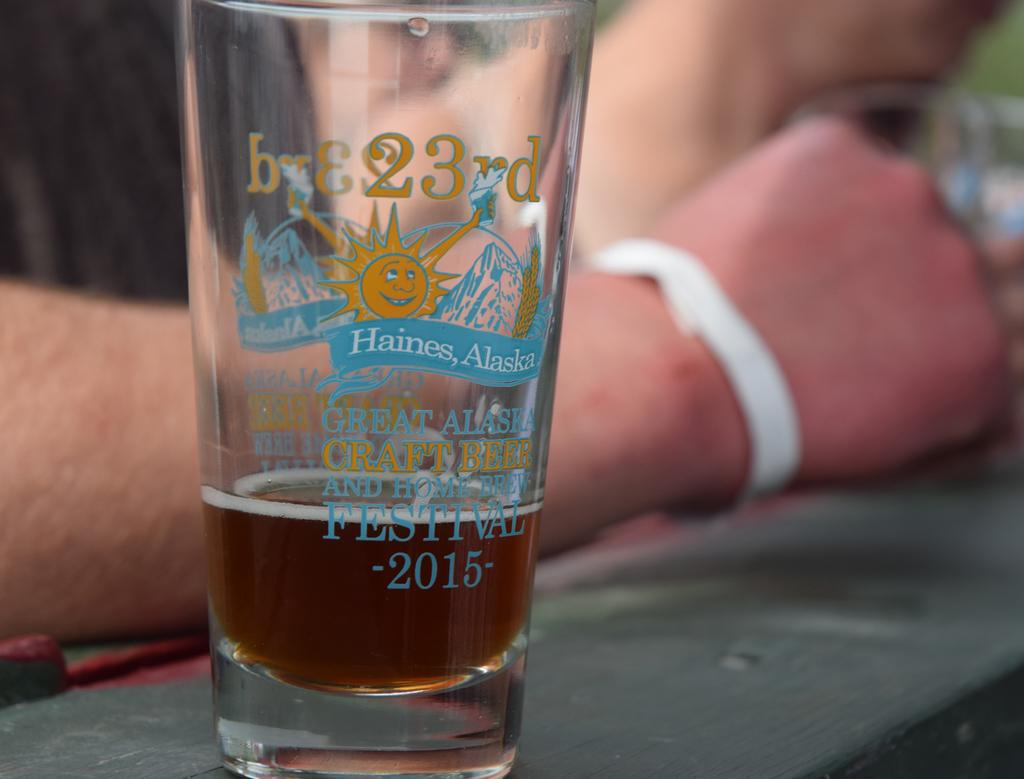What type of living organism is present in the image? There is a human in the image. What object is on a table in the image? There is a glass on a table in the image. Is the human in the image crying or tying a knot in their sock? There is no indication in the image that the human is crying or tying a knot in their sock. 